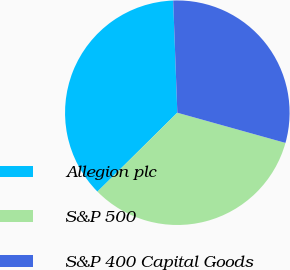Convert chart. <chart><loc_0><loc_0><loc_500><loc_500><pie_chart><fcel>Allegion plc<fcel>S&P 500<fcel>S&P 400 Capital Goods<nl><fcel>36.82%<fcel>33.26%<fcel>29.92%<nl></chart> 